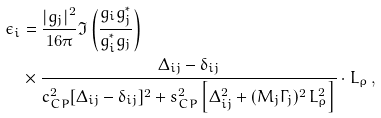<formula> <loc_0><loc_0><loc_500><loc_500>\epsilon _ { i } & = \frac { | g _ { j } | ^ { 2 } } { 1 6 \pi } \Im \left ( \frac { g _ { i } g _ { j } ^ { * } } { g _ { i } ^ { * } g _ { j } } \right ) \\ & \times \frac { \Delta _ { i j } - \delta _ { i j } } { c _ { C P } ^ { 2 } [ \Delta _ { i j } - \delta _ { i j } ] ^ { 2 } + s _ { C P } ^ { 2 } \left [ \Delta _ { i j } ^ { 2 } + ( M _ { j } \Gamma _ { j } ) ^ { 2 } \, L _ { \rho } ^ { 2 } \right ] } \cdot L _ { \rho } \, ,</formula> 